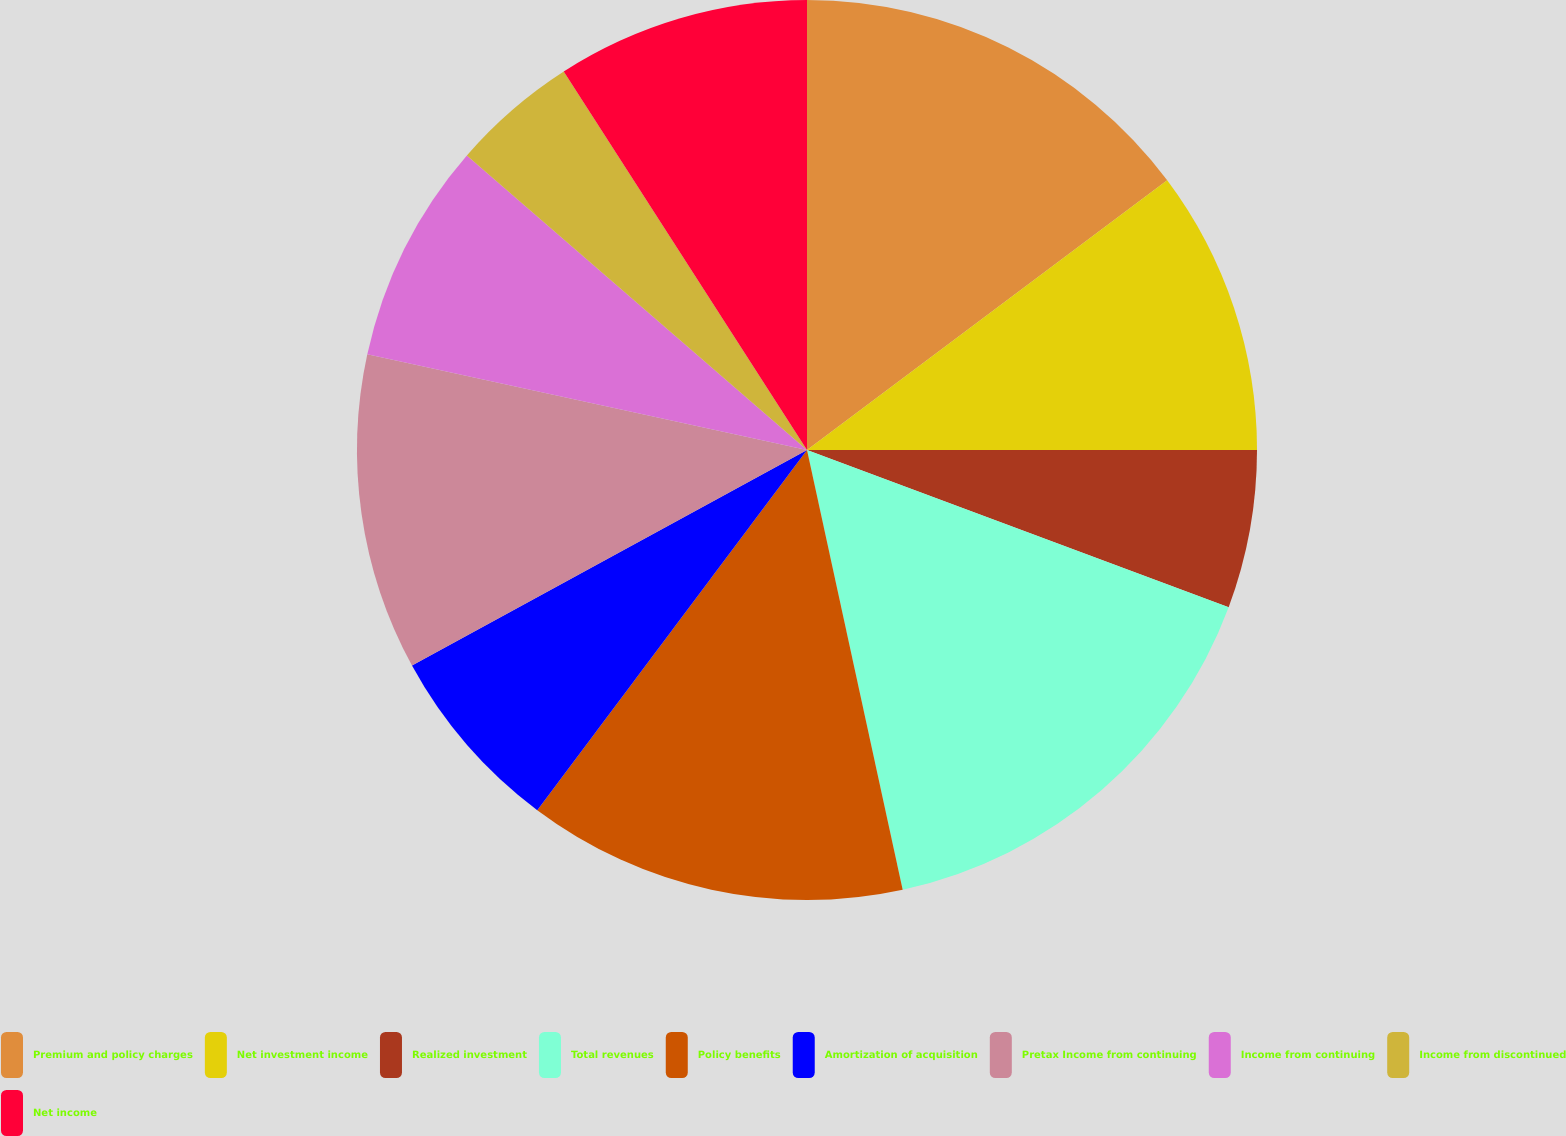Convert chart. <chart><loc_0><loc_0><loc_500><loc_500><pie_chart><fcel>Premium and policy charges<fcel>Net investment income<fcel>Realized investment<fcel>Total revenues<fcel>Policy benefits<fcel>Amortization of acquisition<fcel>Pretax Income from continuing<fcel>Income from continuing<fcel>Income from discontinued<fcel>Net income<nl><fcel>14.77%<fcel>10.23%<fcel>5.68%<fcel>15.91%<fcel>13.64%<fcel>6.82%<fcel>11.36%<fcel>7.95%<fcel>4.55%<fcel>9.09%<nl></chart> 